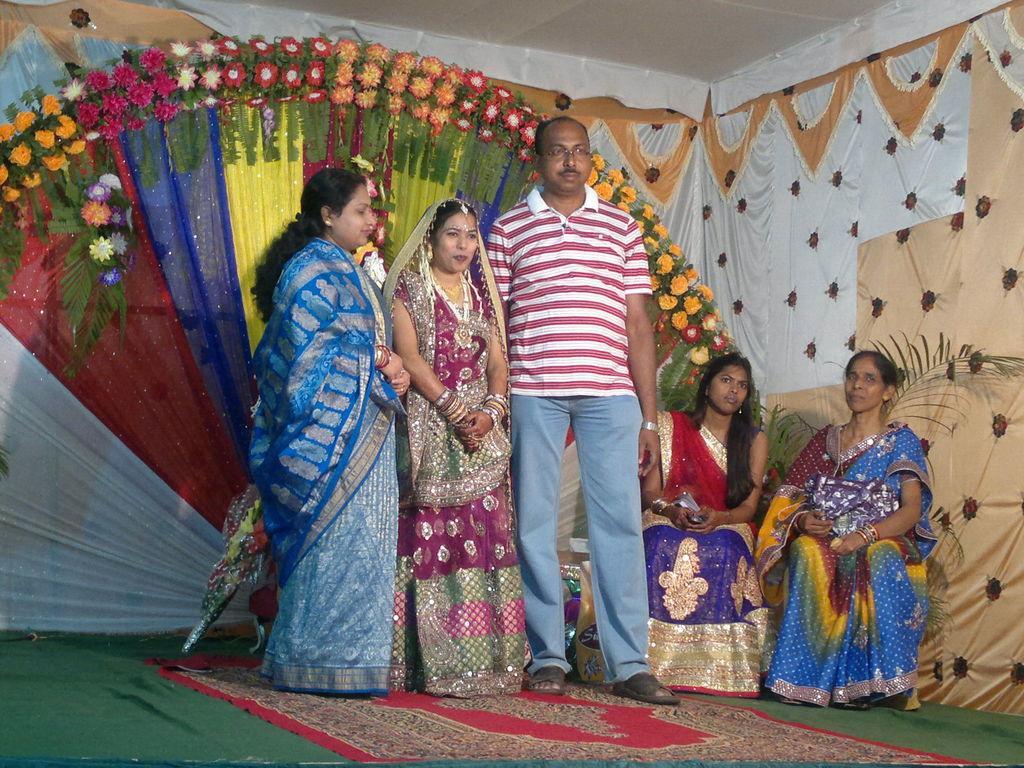Could you give a brief overview of what you see in this image? In this image we can see three people standing on the stage and posing for a photo, behind them, we can see two persons sitting on the chairs, a flower bouquet, few decorative flowers and some clothes and some clothes attached to the wall. 